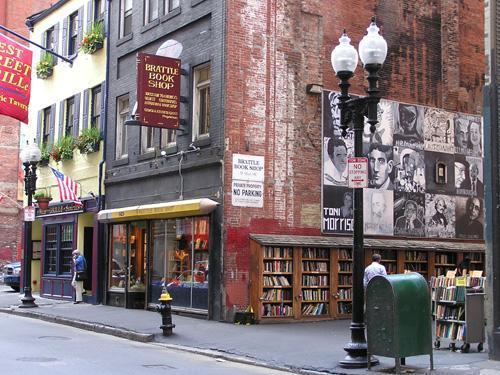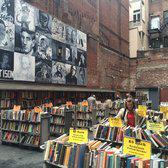The first image is the image on the left, the second image is the image on the right. Assess this claim about the two images: "stairs can be seen in the image on the left". Correct or not? Answer yes or no. No. The first image is the image on the left, the second image is the image on the right. For the images shown, is this caption "A light sits on a pole on the street." true? Answer yes or no. Yes. 